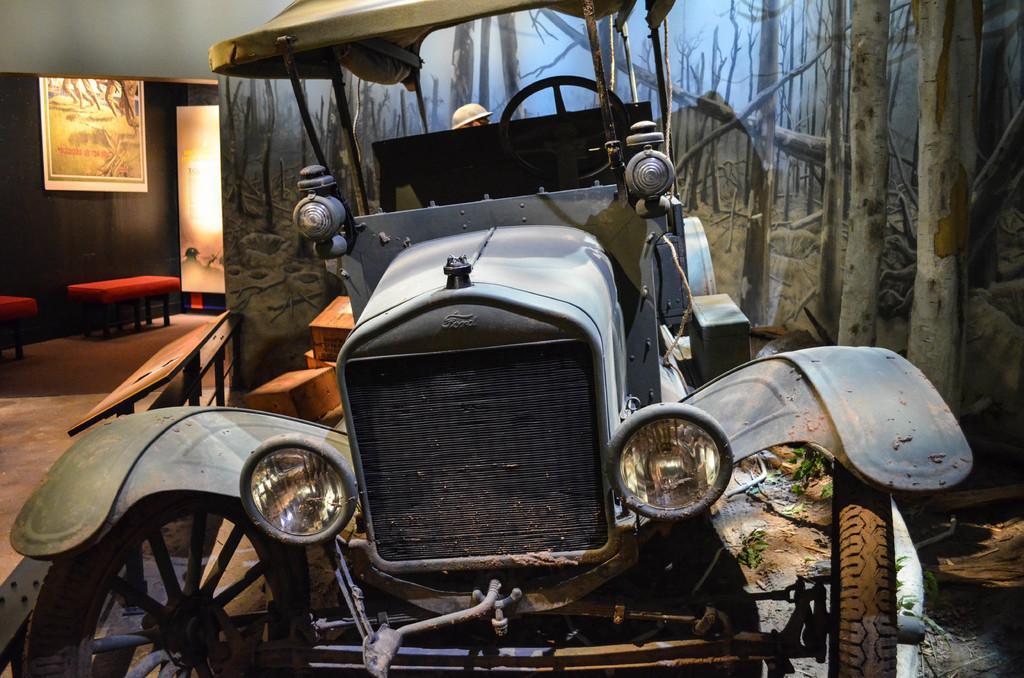Can you describe this image briefly? In this image there is a car, there is a person wearing a helmet, there are boxes on the ground, there are benches, there is a painting on the wall, there is a photo frame on the wall. 